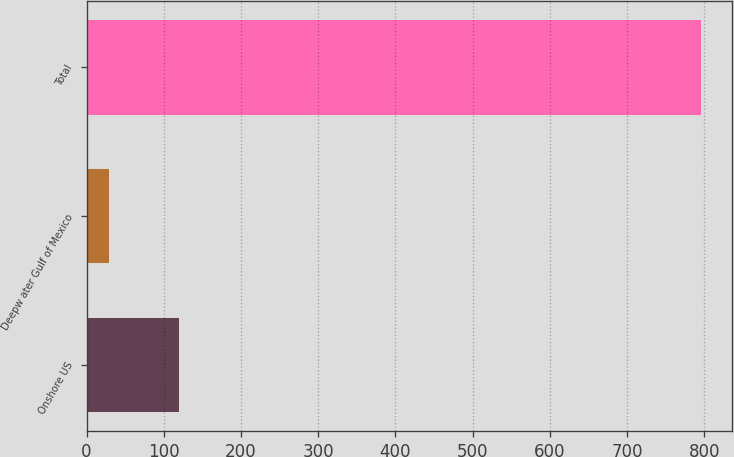Convert chart to OTSL. <chart><loc_0><loc_0><loc_500><loc_500><bar_chart><fcel>Onshore US<fcel>Deepw ater Gulf of Mexico<fcel>Total<nl><fcel>120<fcel>29<fcel>796<nl></chart> 